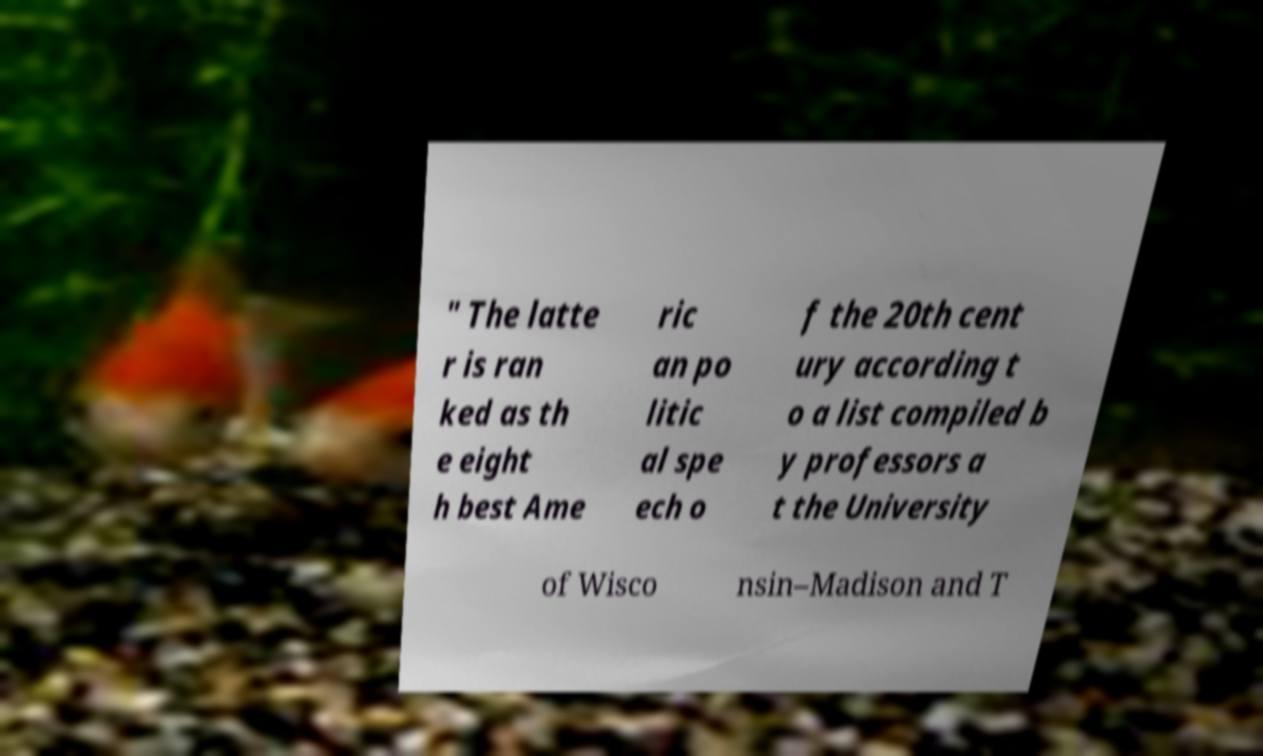There's text embedded in this image that I need extracted. Can you transcribe it verbatim? " The latte r is ran ked as th e eight h best Ame ric an po litic al spe ech o f the 20th cent ury according t o a list compiled b y professors a t the University of Wisco nsin–Madison and T 